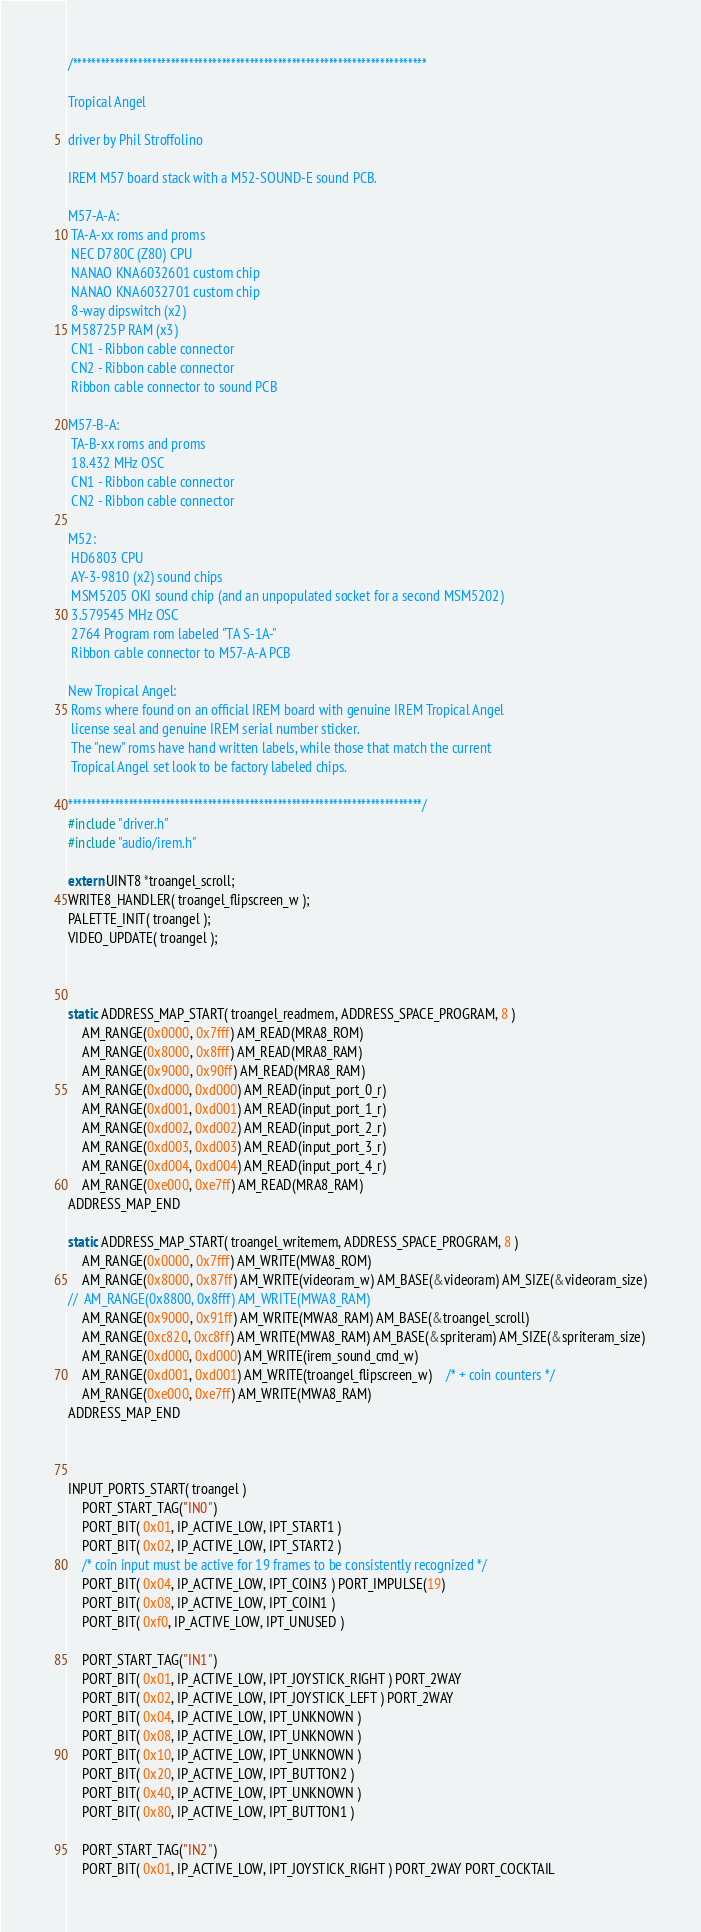Convert code to text. <code><loc_0><loc_0><loc_500><loc_500><_C_>/****************************************************************************

Tropical Angel

driver by Phil Stroffolino

IREM M57 board stack with a M52-SOUND-E sound PCB.

M57-A-A:
 TA-A-xx roms and proms
 NEC D780C (Z80) CPU
 NANAO KNA6032601 custom chip
 NANAO KNA6032701 custom chip
 8-way dipswitch (x2)
 M58725P RAM (x3)
 CN1 - Ribbon cable connector
 CN2 - Ribbon cable connector
 Ribbon cable connector to sound PCB

M57-B-A:
 TA-B-xx roms and proms
 18.432 MHz OSC
 CN1 - Ribbon cable connector
 CN2 - Ribbon cable connector

M52:
 HD6803 CPU
 AY-3-9810 (x2) sound chips
 MSM5205 OKI sound chip (and an unpopulated socket for a second MSM5202)
 3.579545 MHz OSC
 2764 Program rom labeled "TA S-1A-"
 Ribbon cable connector to M57-A-A PCB

New Tropical Angel:
 Roms where found on an official IREM board with genuine IREM Tropical Angel
 license seal and genuine IREM serial number sticker.
 The "new" roms have hand written labels, while those that match the current
 Tropical Angel set look to be factory labeled chips.

****************************************************************************/
#include "driver.h"
#include "audio/irem.h"

extern UINT8 *troangel_scroll;
WRITE8_HANDLER( troangel_flipscreen_w );
PALETTE_INIT( troangel );
VIDEO_UPDATE( troangel );



static ADDRESS_MAP_START( troangel_readmem, ADDRESS_SPACE_PROGRAM, 8 )
	AM_RANGE(0x0000, 0x7fff) AM_READ(MRA8_ROM)
	AM_RANGE(0x8000, 0x8fff) AM_READ(MRA8_RAM)
	AM_RANGE(0x9000, 0x90ff) AM_READ(MRA8_RAM)
	AM_RANGE(0xd000, 0xd000) AM_READ(input_port_0_r)
	AM_RANGE(0xd001, 0xd001) AM_READ(input_port_1_r)
	AM_RANGE(0xd002, 0xd002) AM_READ(input_port_2_r)
	AM_RANGE(0xd003, 0xd003) AM_READ(input_port_3_r)
	AM_RANGE(0xd004, 0xd004) AM_READ(input_port_4_r)
	AM_RANGE(0xe000, 0xe7ff) AM_READ(MRA8_RAM)
ADDRESS_MAP_END

static ADDRESS_MAP_START( troangel_writemem, ADDRESS_SPACE_PROGRAM, 8 )
	AM_RANGE(0x0000, 0x7fff) AM_WRITE(MWA8_ROM)
	AM_RANGE(0x8000, 0x87ff) AM_WRITE(videoram_w) AM_BASE(&videoram) AM_SIZE(&videoram_size)
//  AM_RANGE(0x8800, 0x8fff) AM_WRITE(MWA8_RAM)
	AM_RANGE(0x9000, 0x91ff) AM_WRITE(MWA8_RAM) AM_BASE(&troangel_scroll)
	AM_RANGE(0xc820, 0xc8ff) AM_WRITE(MWA8_RAM) AM_BASE(&spriteram) AM_SIZE(&spriteram_size)
	AM_RANGE(0xd000, 0xd000) AM_WRITE(irem_sound_cmd_w)
	AM_RANGE(0xd001, 0xd001) AM_WRITE(troangel_flipscreen_w)	/* + coin counters */
	AM_RANGE(0xe000, 0xe7ff) AM_WRITE(MWA8_RAM)
ADDRESS_MAP_END



INPUT_PORTS_START( troangel )
	PORT_START_TAG("IN0")
	PORT_BIT( 0x01, IP_ACTIVE_LOW, IPT_START1 )
	PORT_BIT( 0x02, IP_ACTIVE_LOW, IPT_START2 )
	/* coin input must be active for 19 frames to be consistently recognized */
	PORT_BIT( 0x04, IP_ACTIVE_LOW, IPT_COIN3 ) PORT_IMPULSE(19)
	PORT_BIT( 0x08, IP_ACTIVE_LOW, IPT_COIN1 )
	PORT_BIT( 0xf0, IP_ACTIVE_LOW, IPT_UNUSED )

	PORT_START_TAG("IN1")
	PORT_BIT( 0x01, IP_ACTIVE_LOW, IPT_JOYSTICK_RIGHT ) PORT_2WAY
	PORT_BIT( 0x02, IP_ACTIVE_LOW, IPT_JOYSTICK_LEFT ) PORT_2WAY
	PORT_BIT( 0x04, IP_ACTIVE_LOW, IPT_UNKNOWN )
	PORT_BIT( 0x08, IP_ACTIVE_LOW, IPT_UNKNOWN )
	PORT_BIT( 0x10, IP_ACTIVE_LOW, IPT_UNKNOWN )
	PORT_BIT( 0x20, IP_ACTIVE_LOW, IPT_BUTTON2 )
	PORT_BIT( 0x40, IP_ACTIVE_LOW, IPT_UNKNOWN )
	PORT_BIT( 0x80, IP_ACTIVE_LOW, IPT_BUTTON1 )

	PORT_START_TAG("IN2")
	PORT_BIT( 0x01, IP_ACTIVE_LOW, IPT_JOYSTICK_RIGHT ) PORT_2WAY PORT_COCKTAIL</code> 